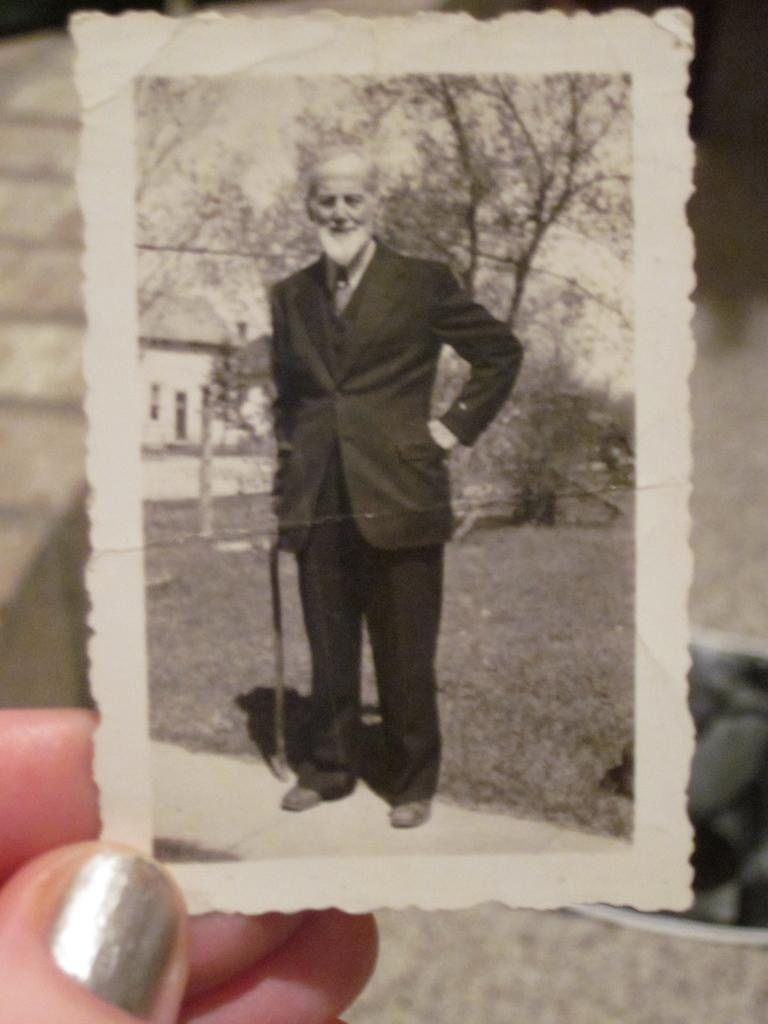What can be seen in the left bottom corner of the image? There are fingers of a person in the left bottom corner of the image. What is the main subject of the photograph in the image? There is a photograph of a man in the image. What is the man in the photograph wearing? The man in the photograph is wearing a suit. What object is the man in the photograph holding? The man in the photograph is holding a walking stick. What can be seen in the background of the photograph? There are trees and a building visible in the background of the photograph. How many friends are visible in the image? There are no friends visible in the image; the image only contains a photograph of a man. What type of health issues does the man in the photograph have? There is no information about the man's health in the image. 